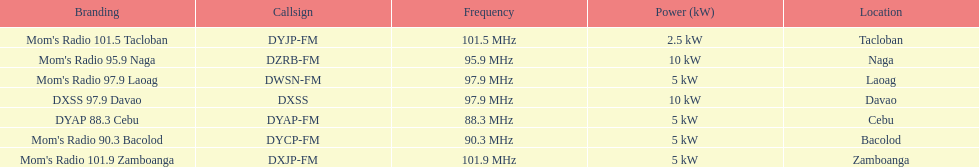Help me parse the entirety of this table. {'header': ['Branding', 'Callsign', 'Frequency', 'Power (kW)', 'Location'], 'rows': [["Mom's Radio 101.5 Tacloban", 'DYJP-FM', '101.5\xa0MHz', '2.5\xa0kW', 'Tacloban'], ["Mom's Radio 95.9 Naga", 'DZRB-FM', '95.9\xa0MHz', '10\xa0kW', 'Naga'], ["Mom's Radio 97.9 Laoag", 'DWSN-FM', '97.9\xa0MHz', '5\xa0kW', 'Laoag'], ['DXSS 97.9 Davao', 'DXSS', '97.9\xa0MHz', '10\xa0kW', 'Davao'], ['DYAP 88.3 Cebu', 'DYAP-FM', '88.3\xa0MHz', '5\xa0kW', 'Cebu'], ["Mom's Radio 90.3 Bacolod", 'DYCP-FM', '90.3\xa0MHz', '5\xa0kW', 'Bacolod'], ["Mom's Radio 101.9 Zamboanga", 'DXJP-FM', '101.9\xa0MHz', '5\xa0kW', 'Zamboanga']]} What is the difference in kw between naga and bacolod radio? 5 kW. 